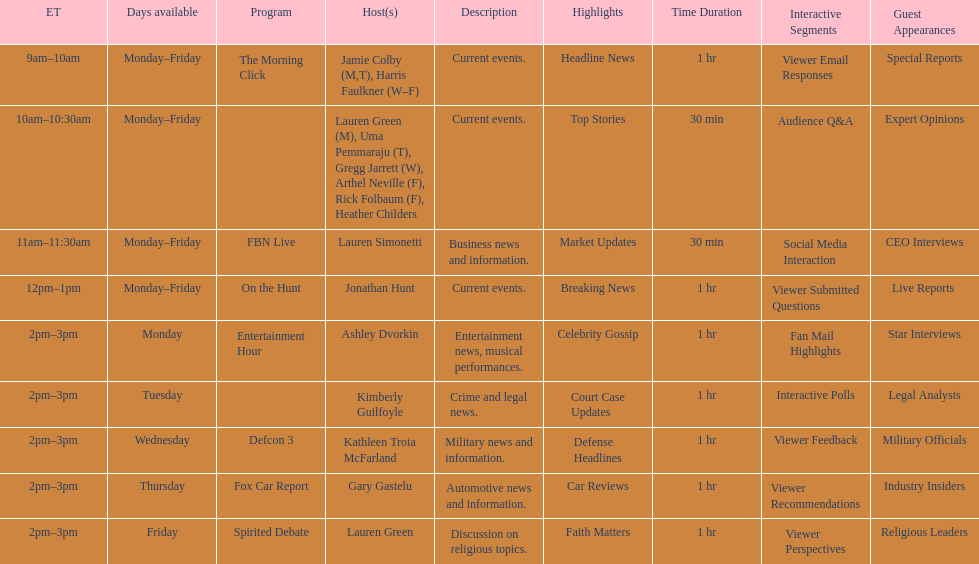Tell me the number of shows that only have one host per day. 7. 